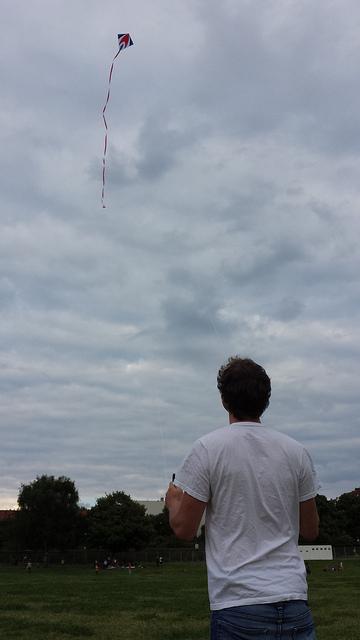Who is flying the kite?
Short answer required. Man. Why might the person be looking back?
Give a very brief answer. Kite. Is it a sunny day?
Keep it brief. No. What is above the person?
Write a very short answer. Kite. What is the man looking at?
Short answer required. Kite. In what city is this man flying his kite?
Answer briefly. Los angeles. How does the kite stay in the air?
Answer briefly. Wind. Is the highest kite being flown by a male or female?
Be succinct. Male. 